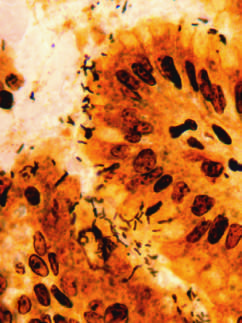what are organisms abundant within?
Answer the question using a single word or phrase. Surface mucus 